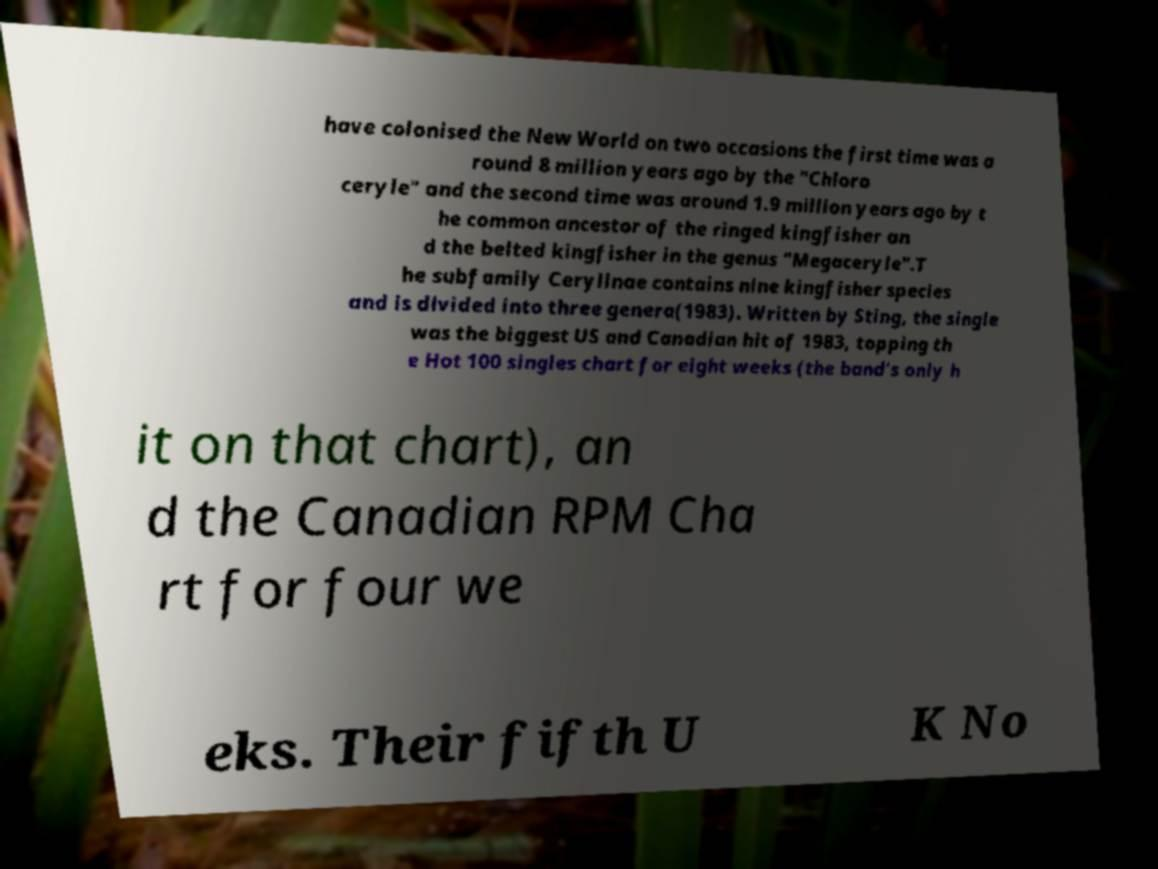Please read and relay the text visible in this image. What does it say? have colonised the New World on two occasions the first time was a round 8 million years ago by the "Chloro ceryle" and the second time was around 1.9 million years ago by t he common ancestor of the ringed kingfisher an d the belted kingfisher in the genus "Megaceryle".T he subfamily Cerylinae contains nine kingfisher species and is divided into three genera(1983). Written by Sting, the single was the biggest US and Canadian hit of 1983, topping th e Hot 100 singles chart for eight weeks (the band's only h it on that chart), an d the Canadian RPM Cha rt for four we eks. Their fifth U K No 